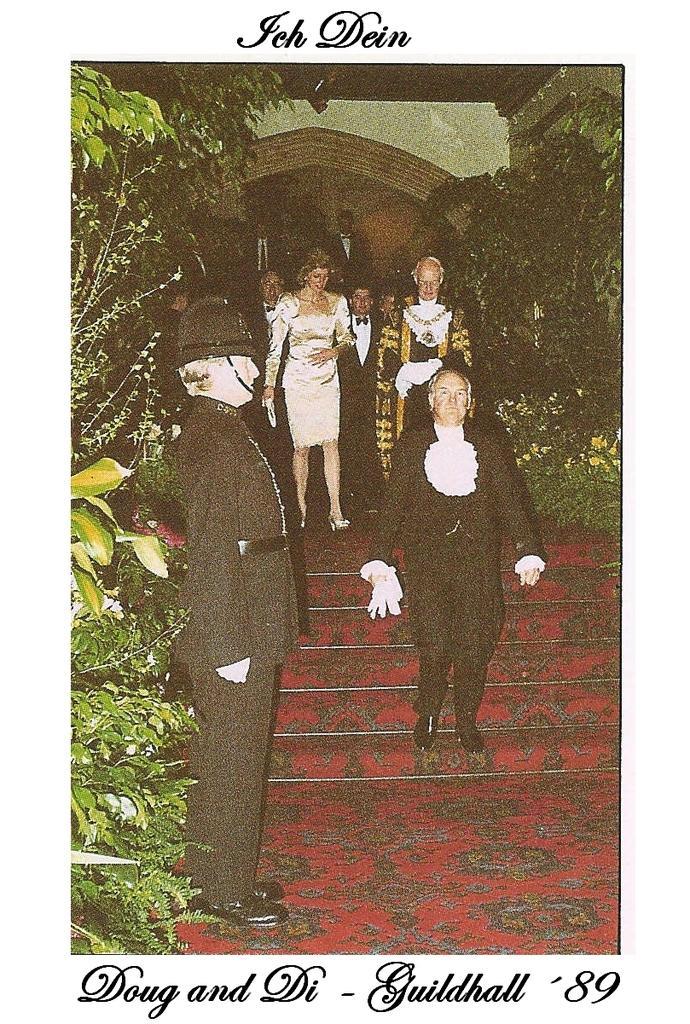Describe this image in one or two sentences. In this image, we can see a poster. In this poster, we can see few people, plants, stairs and walls. At the top and bottom of the image, we can see some information. 